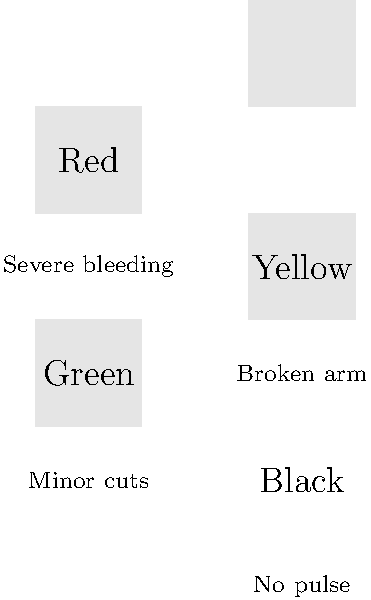Based on the triage tags and associated symptoms shown in the image, arrange the tags in the correct order of priority for emergency treatment, from highest to lowest. To determine the correct sequence of triage tags, we need to assess the severity of each symptom and prioritize accordingly:

1. Red tag - "Severe bleeding": This is a life-threatening condition that requires immediate attention. Severe blood loss can lead to shock and death if not treated promptly.

2. Yellow tag - "Broken arm": While painful and requiring treatment, a broken arm is not immediately life-threatening. It's considered an urgent case but can wait briefly if more critical patients need attention.

3. Green tag - "Minor cuts": These are non-urgent injuries that can wait for treatment without risk of further complications.

4. Black tag - "No pulse": In a mass casualty situation, a patient with no pulse would typically be considered deceased or unsalvageable, and resources would be directed to those with a higher chance of survival.

The correct order of priority, from highest to lowest, is:

1. Red (immediate)
2. Yellow (urgent)
3. Green (delayed)
4. Black (deceased/expectant)

This order follows the START (Simple Triage and Rapid Treatment) method commonly used in emergency situations.
Answer: Red, Yellow, Green, Black 